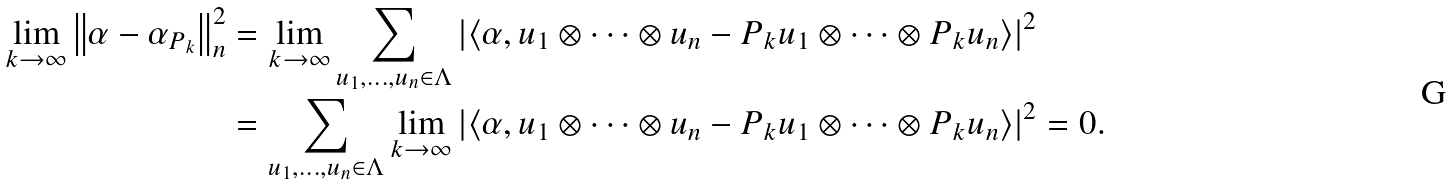Convert formula to latex. <formula><loc_0><loc_0><loc_500><loc_500>\lim _ { k \rightarrow \infty } \left \| \alpha - \alpha _ { P _ { k } } \right \| _ { n } ^ { 2 } & = \lim _ { k \rightarrow \infty } \sum _ { u _ { 1 } , \dots , u _ { n } \in \Lambda } \left | \left \langle \alpha , u _ { 1 } \otimes \dots \otimes u _ { n } - P _ { k } u _ { 1 } \otimes \dots \otimes P _ { k } u _ { n } \right \rangle \right | ^ { 2 } \\ & = \sum _ { u _ { 1 } , \dots , u _ { n } \in \Lambda } \lim _ { k \rightarrow \infty } \left | \left \langle \alpha , u _ { 1 } \otimes \dots \otimes u _ { n } - P _ { k } u _ { 1 } \otimes \dots \otimes P _ { k } u _ { n } \right \rangle \right | ^ { 2 } = 0 .</formula> 